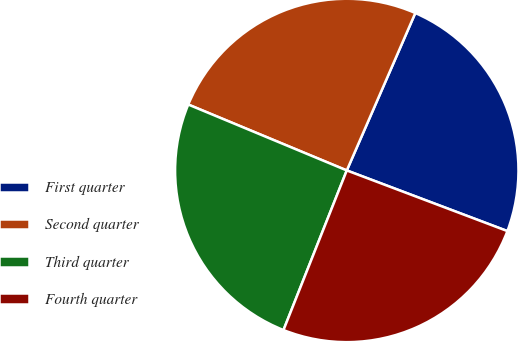Convert chart to OTSL. <chart><loc_0><loc_0><loc_500><loc_500><pie_chart><fcel>First quarter<fcel>Second quarter<fcel>Third quarter<fcel>Fourth quarter<nl><fcel>24.21%<fcel>25.26%<fcel>25.26%<fcel>25.26%<nl></chart> 